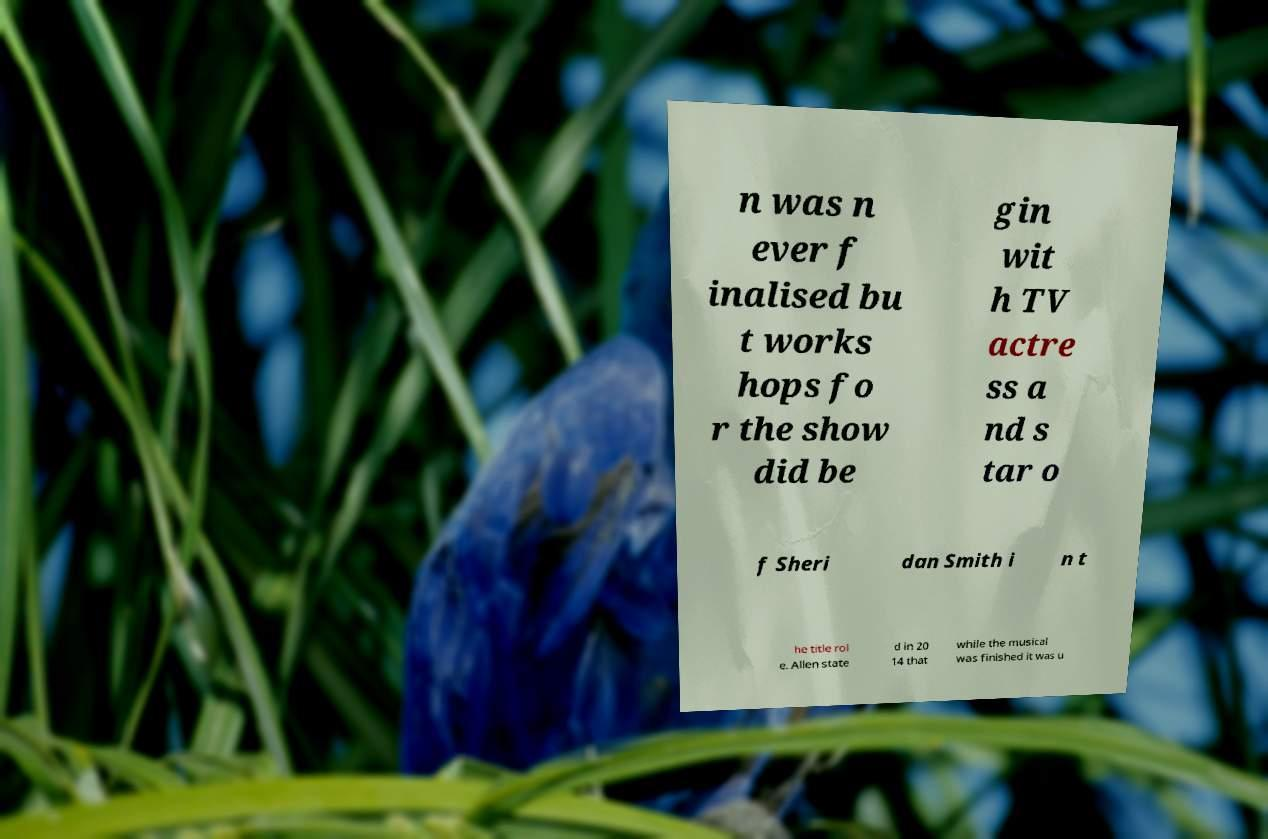Can you accurately transcribe the text from the provided image for me? n was n ever f inalised bu t works hops fo r the show did be gin wit h TV actre ss a nd s tar o f Sheri dan Smith i n t he title rol e. Allen state d in 20 14 that while the musical was finished it was u 